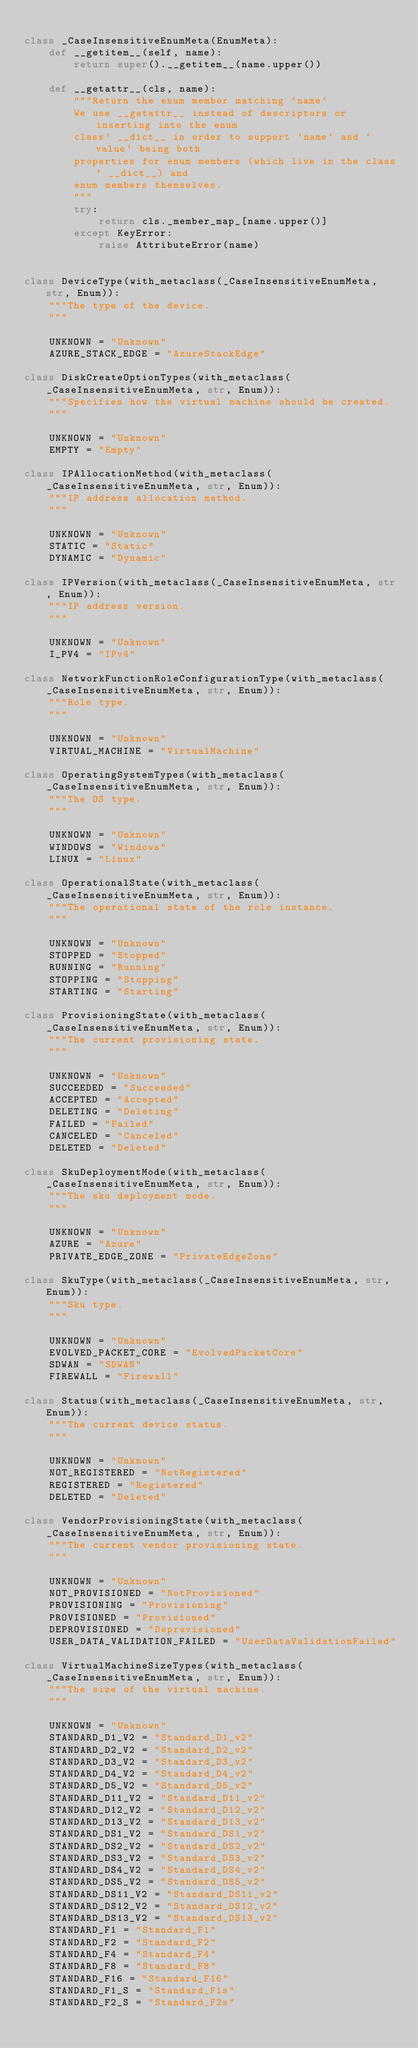<code> <loc_0><loc_0><loc_500><loc_500><_Python_>
class _CaseInsensitiveEnumMeta(EnumMeta):
    def __getitem__(self, name):
        return super().__getitem__(name.upper())

    def __getattr__(cls, name):
        """Return the enum member matching `name`
        We use __getattr__ instead of descriptors or inserting into the enum
        class' __dict__ in order to support `name` and `value` being both
        properties for enum members (which live in the class' __dict__) and
        enum members themselves.
        """
        try:
            return cls._member_map_[name.upper()]
        except KeyError:
            raise AttributeError(name)


class DeviceType(with_metaclass(_CaseInsensitiveEnumMeta, str, Enum)):
    """The type of the device.
    """

    UNKNOWN = "Unknown"
    AZURE_STACK_EDGE = "AzureStackEdge"

class DiskCreateOptionTypes(with_metaclass(_CaseInsensitiveEnumMeta, str, Enum)):
    """Specifies how the virtual machine should be created.
    """

    UNKNOWN = "Unknown"
    EMPTY = "Empty"

class IPAllocationMethod(with_metaclass(_CaseInsensitiveEnumMeta, str, Enum)):
    """IP address allocation method.
    """

    UNKNOWN = "Unknown"
    STATIC = "Static"
    DYNAMIC = "Dynamic"

class IPVersion(with_metaclass(_CaseInsensitiveEnumMeta, str, Enum)):
    """IP address version.
    """

    UNKNOWN = "Unknown"
    I_PV4 = "IPv4"

class NetworkFunctionRoleConfigurationType(with_metaclass(_CaseInsensitiveEnumMeta, str, Enum)):
    """Role type.
    """

    UNKNOWN = "Unknown"
    VIRTUAL_MACHINE = "VirtualMachine"

class OperatingSystemTypes(with_metaclass(_CaseInsensitiveEnumMeta, str, Enum)):
    """The OS type.
    """

    UNKNOWN = "Unknown"
    WINDOWS = "Windows"
    LINUX = "Linux"

class OperationalState(with_metaclass(_CaseInsensitiveEnumMeta, str, Enum)):
    """The operational state of the role instance.
    """

    UNKNOWN = "Unknown"
    STOPPED = "Stopped"
    RUNNING = "Running"
    STOPPING = "Stopping"
    STARTING = "Starting"

class ProvisioningState(with_metaclass(_CaseInsensitiveEnumMeta, str, Enum)):
    """The current provisioning state.
    """

    UNKNOWN = "Unknown"
    SUCCEEDED = "Succeeded"
    ACCEPTED = "Accepted"
    DELETING = "Deleting"
    FAILED = "Failed"
    CANCELED = "Canceled"
    DELETED = "Deleted"

class SkuDeploymentMode(with_metaclass(_CaseInsensitiveEnumMeta, str, Enum)):
    """The sku deployment mode.
    """

    UNKNOWN = "Unknown"
    AZURE = "Azure"
    PRIVATE_EDGE_ZONE = "PrivateEdgeZone"

class SkuType(with_metaclass(_CaseInsensitiveEnumMeta, str, Enum)):
    """Sku type.
    """

    UNKNOWN = "Unknown"
    EVOLVED_PACKET_CORE = "EvolvedPacketCore"
    SDWAN = "SDWAN"
    FIREWALL = "Firewall"

class Status(with_metaclass(_CaseInsensitiveEnumMeta, str, Enum)):
    """The current device status.
    """

    UNKNOWN = "Unknown"
    NOT_REGISTERED = "NotRegistered"
    REGISTERED = "Registered"
    DELETED = "Deleted"

class VendorProvisioningState(with_metaclass(_CaseInsensitiveEnumMeta, str, Enum)):
    """The current vendor provisioning state.
    """

    UNKNOWN = "Unknown"
    NOT_PROVISIONED = "NotProvisioned"
    PROVISIONING = "Provisioning"
    PROVISIONED = "Provisioned"
    DEPROVISIONED = "Deprovisioned"
    USER_DATA_VALIDATION_FAILED = "UserDataValidationFailed"

class VirtualMachineSizeTypes(with_metaclass(_CaseInsensitiveEnumMeta, str, Enum)):
    """The size of the virtual machine.
    """

    UNKNOWN = "Unknown"
    STANDARD_D1_V2 = "Standard_D1_v2"
    STANDARD_D2_V2 = "Standard_D2_v2"
    STANDARD_D3_V2 = "Standard_D3_v2"
    STANDARD_D4_V2 = "Standard_D4_v2"
    STANDARD_D5_V2 = "Standard_D5_v2"
    STANDARD_D11_V2 = "Standard_D11_v2"
    STANDARD_D12_V2 = "Standard_D12_v2"
    STANDARD_D13_V2 = "Standard_D13_v2"
    STANDARD_DS1_V2 = "Standard_DS1_v2"
    STANDARD_DS2_V2 = "Standard_DS2_v2"
    STANDARD_DS3_V2 = "Standard_DS3_v2"
    STANDARD_DS4_V2 = "Standard_DS4_v2"
    STANDARD_DS5_V2 = "Standard_DS5_v2"
    STANDARD_DS11_V2 = "Standard_DS11_v2"
    STANDARD_DS12_V2 = "Standard_DS12_v2"
    STANDARD_DS13_V2 = "Standard_DS13_v2"
    STANDARD_F1 = "Standard_F1"
    STANDARD_F2 = "Standard_F2"
    STANDARD_F4 = "Standard_F4"
    STANDARD_F8 = "Standard_F8"
    STANDARD_F16 = "Standard_F16"
    STANDARD_F1_S = "Standard_F1s"
    STANDARD_F2_S = "Standard_F2s"</code> 